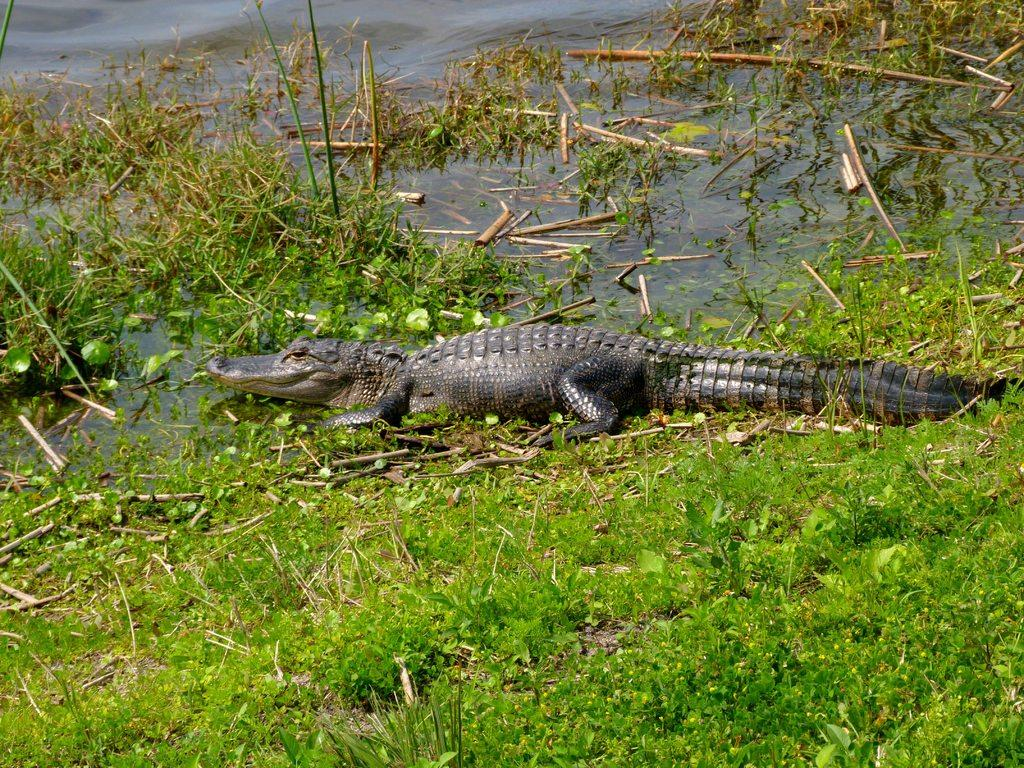What animal is present in the image? There is a crocodile in the image. Where is the crocodile located? The crocodile is on the surface of the water. What type of vegetation can be seen in the image? There is grass visible in the image. What type of pot is being used to collect the blood in the image? There is no pot or blood present in the image; it features a crocodile on the surface of the water and grass. 